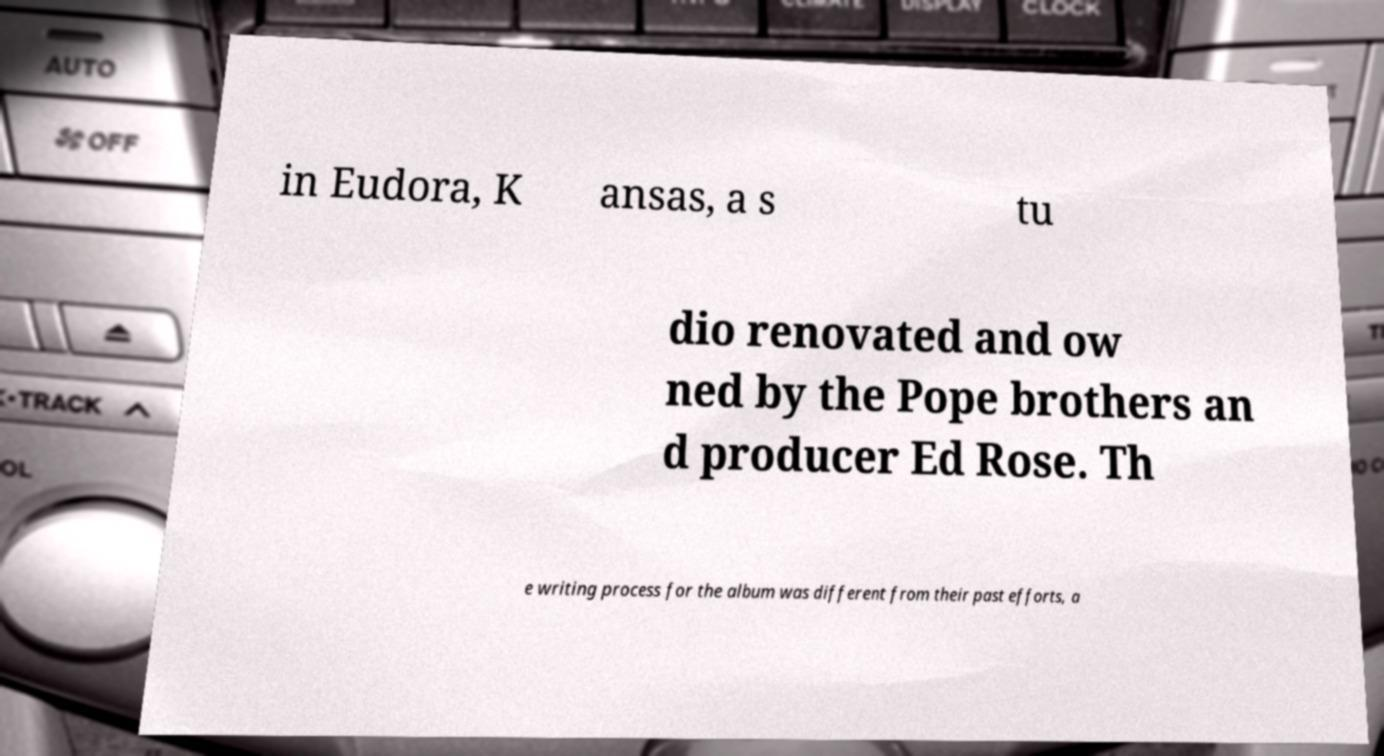What messages or text are displayed in this image? I need them in a readable, typed format. in Eudora, K ansas, a s tu dio renovated and ow ned by the Pope brothers an d producer Ed Rose. Th e writing process for the album was different from their past efforts, a 